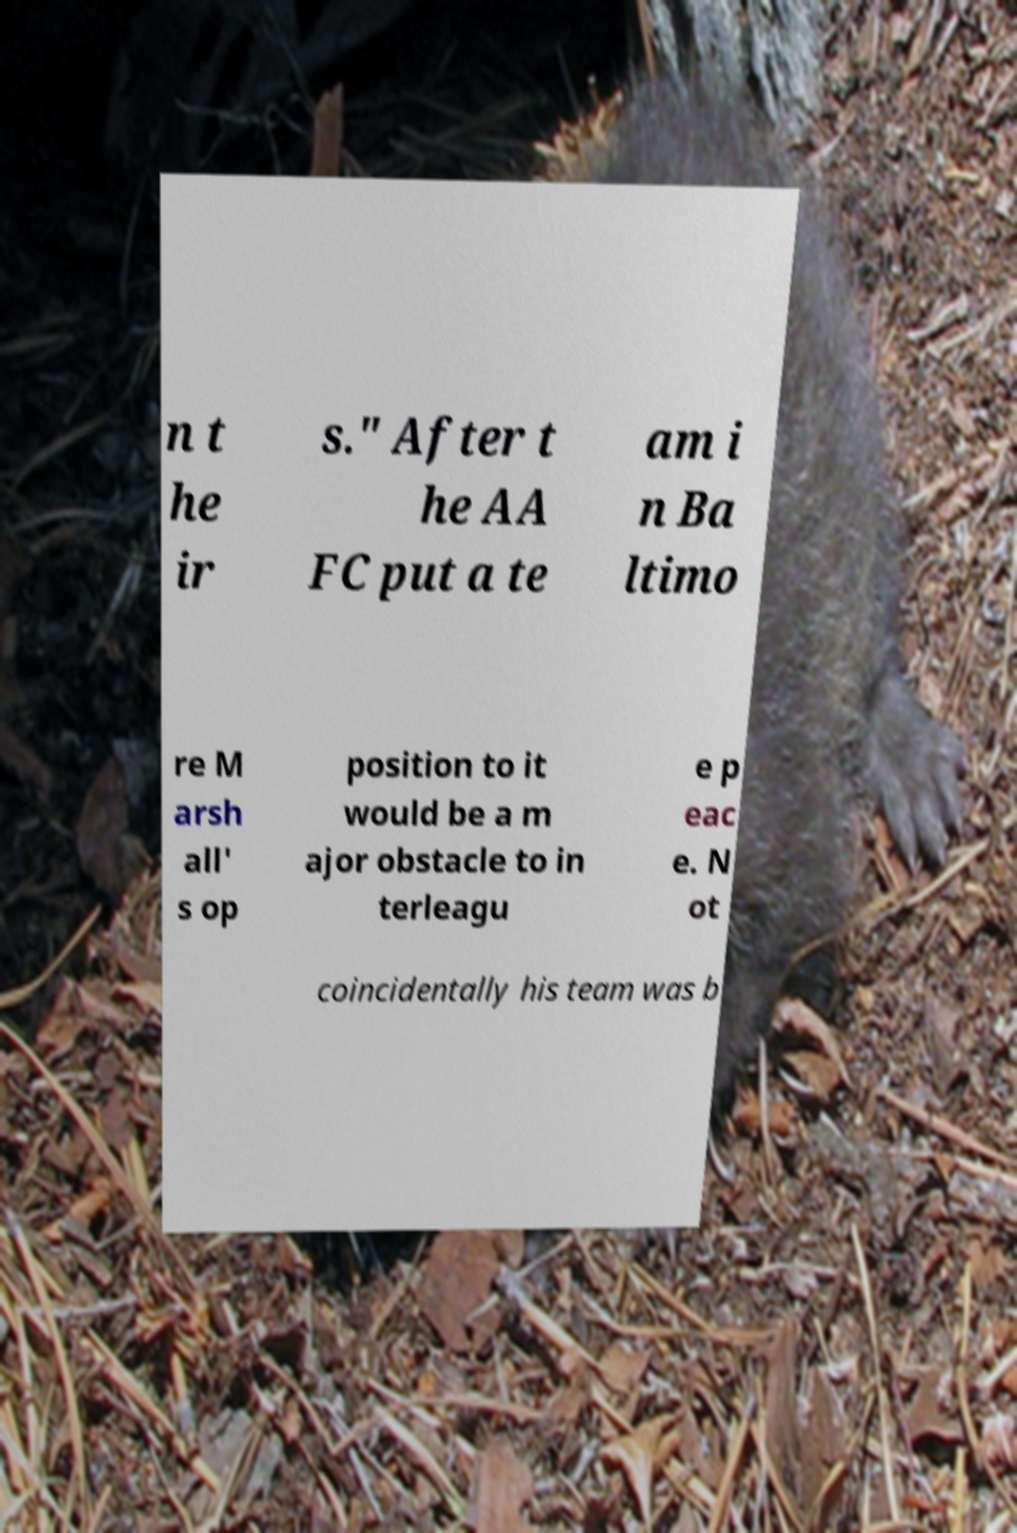Can you accurately transcribe the text from the provided image for me? n t he ir s." After t he AA FC put a te am i n Ba ltimo re M arsh all' s op position to it would be a m ajor obstacle to in terleagu e p eac e. N ot coincidentally his team was b 